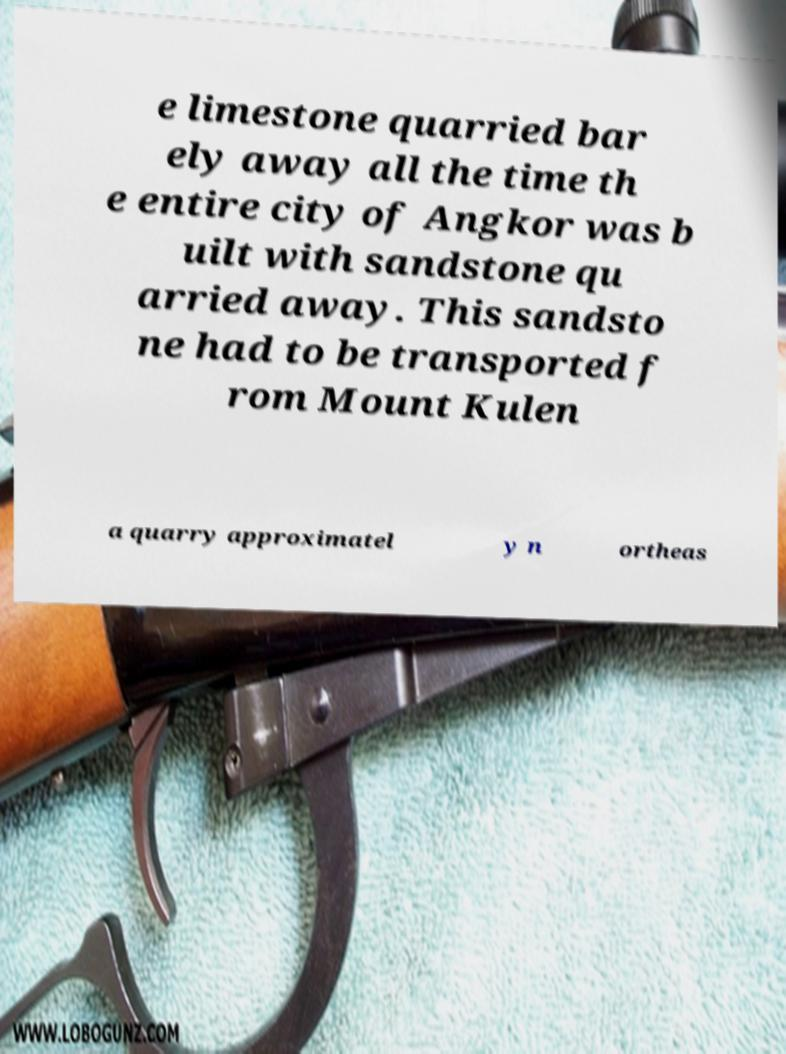For documentation purposes, I need the text within this image transcribed. Could you provide that? e limestone quarried bar ely away all the time th e entire city of Angkor was b uilt with sandstone qu arried away. This sandsto ne had to be transported f rom Mount Kulen a quarry approximatel y n ortheas 